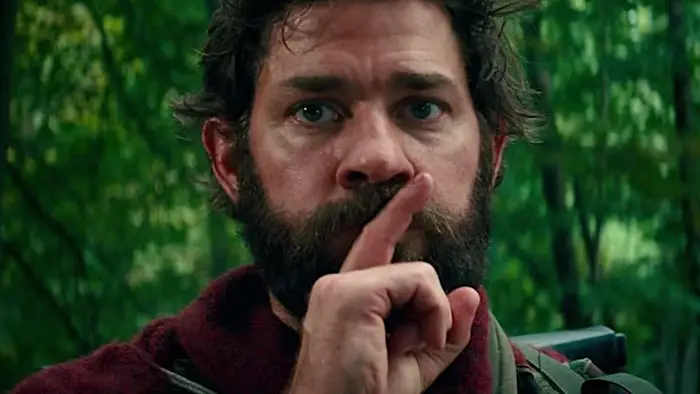What kind of scenario might this image depict in a post-apocalyptic world? In a post-apocalyptic world, this scene might depict a moment where the character is navigating through a highly dangerous area where remaining silent is crucial for survival. This could be a world overrun by creatures that hunt by sound, or filled with hostile factions where any noise could alert enemies. The character's alertness and gesture for silence indicate a high-stakes situation, possibly involving the rescue or protection of loved ones or a mission to secure essential resources. What are some possible everyday dangers in such a world that require silence? In a post-apocalyptic world where silence is essential, everyday dangers could include: creatures with advanced hearing abilities, groups of hostile survivors who patrol and attack suspected intruders, and natural hazards like unstable structures that could collapse at any loud noise. Additionally, setting off any noise might attract scavengers or lead to detection by automated security systems left over from before the apocalypse. Every movement and decision must be carefully calculated to avoid these threats. Describe a day in the life of this character. A typical day for this character would involve waking up before dawn to ensure they remain undetected. Their morning would be spent scouting for safe routes and foraging for food. Every task, from gathering supplies to repairing gear, would be performed with utmost silence. Navigating through the densely forested area would require constant vigilance, avoiding any dry branches that could snap underfoot. He might spend a considerable portion of the day assessing threats or planning the next safe haven to relocate. The evening would involve setting up traps or warnings against nocturnal predators, followed by a brief, restless sleep, as even the slightest disturbance could mean peril. Create an imaginative question that dives into the character's psyche. If this character could communicate with the unseen creatures in the forest without breaking the silence, what secrets or bargains might he attempt to uncover or negotiate? 
Imagine this image is part of a grand mythos. What could be the legend behind the character and the forest? In the grand mythos, this character could be known as the 'Silence Guardian,' a figure tasked by ancient forest spirits with maintaining peace within the woods. The legend tells of a time when the forest was desecrated by invaders, causing the spirits to summon champions who could use their wits and silence to protect the sacred land. The Silence Guardian, clad in his distinguishing red cloak, would patrol the forest, confronting and outwitting beings drawn to noise. It is said he possesses a unique ability to communicate telepathically with the forest creatures, gathering vital information to thwart threats. This silent sentinel's duty is both a curse and a blessing, for while he maintains the balance, he can never break his vow of silence, lest he awaken the wrath of the spirits. 